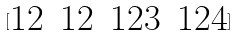<formula> <loc_0><loc_0><loc_500><loc_500>[ \begin{matrix} 1 2 & 1 2 & 1 2 3 & 1 2 4 \\ \end{matrix} ]</formula> 